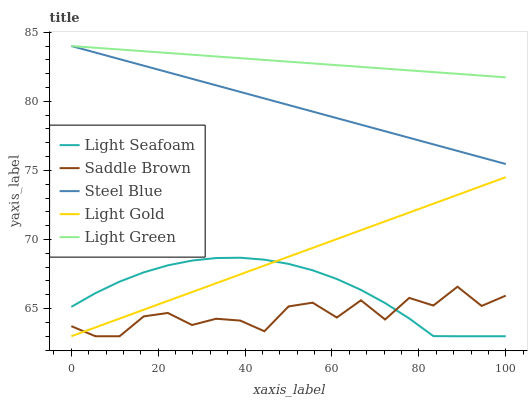Does Saddle Brown have the minimum area under the curve?
Answer yes or no. Yes. Does Light Green have the maximum area under the curve?
Answer yes or no. Yes. Does Light Gold have the minimum area under the curve?
Answer yes or no. No. Does Light Gold have the maximum area under the curve?
Answer yes or no. No. Is Light Gold the smoothest?
Answer yes or no. Yes. Is Saddle Brown the roughest?
Answer yes or no. Yes. Is Saddle Brown the smoothest?
Answer yes or no. No. Is Light Gold the roughest?
Answer yes or no. No. Does Light Seafoam have the lowest value?
Answer yes or no. Yes. Does Light Green have the lowest value?
Answer yes or no. No. Does Steel Blue have the highest value?
Answer yes or no. Yes. Does Light Gold have the highest value?
Answer yes or no. No. Is Light Gold less than Light Green?
Answer yes or no. Yes. Is Steel Blue greater than Light Gold?
Answer yes or no. Yes. Does Light Gold intersect Light Seafoam?
Answer yes or no. Yes. Is Light Gold less than Light Seafoam?
Answer yes or no. No. Is Light Gold greater than Light Seafoam?
Answer yes or no. No. Does Light Gold intersect Light Green?
Answer yes or no. No. 